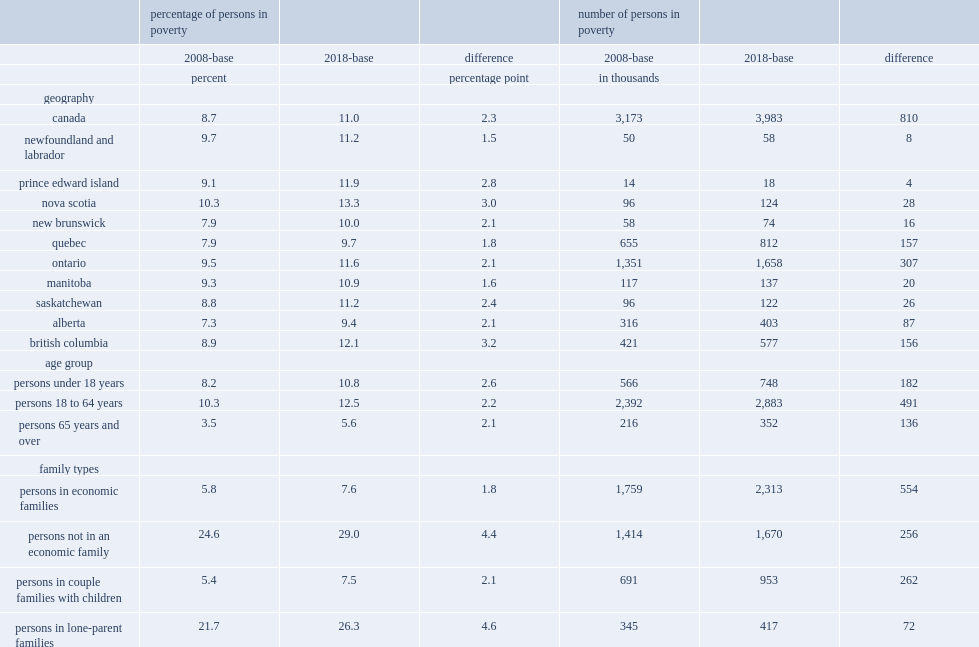What is the 2008-base poverty rate at the canada level in 2018? 8.7. What is the 2018-base poverty rate at the canada level in 2018? 11.0. At the canada level, what is the difference between 2008-base poverty rate and 2018-base poverty rate in 2018? 2.3. 